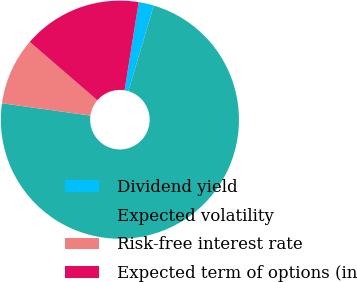Convert chart. <chart><loc_0><loc_0><loc_500><loc_500><pie_chart><fcel>Dividend yield<fcel>Expected volatility<fcel>Risk-free interest rate<fcel>Expected term of options (in<nl><fcel>2.06%<fcel>72.62%<fcel>9.13%<fcel>16.19%<nl></chart> 